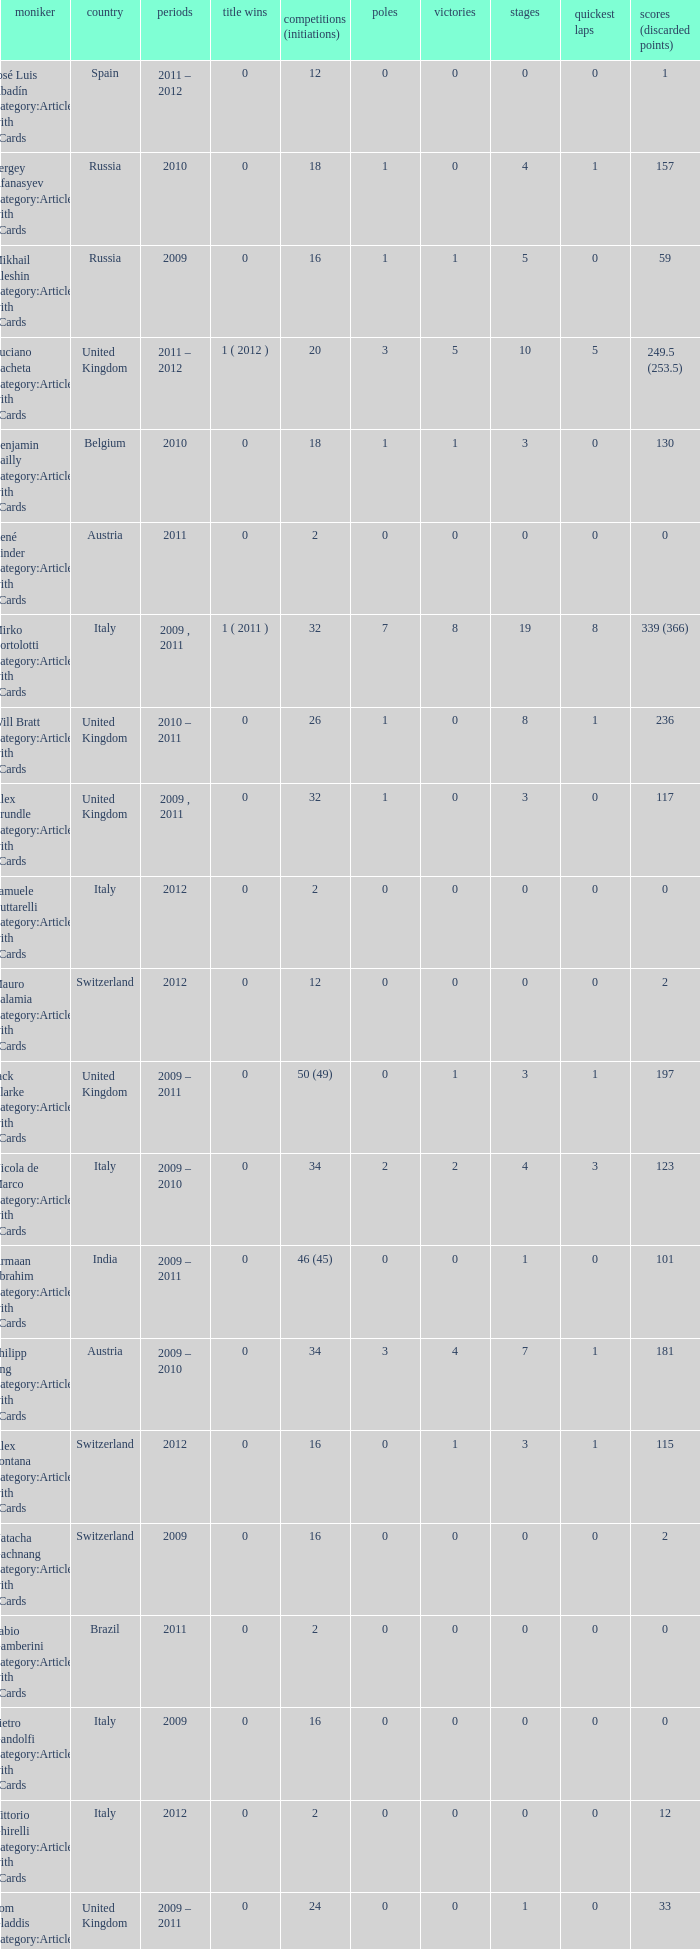What were the starts when the points dropped 18? 8.0. 